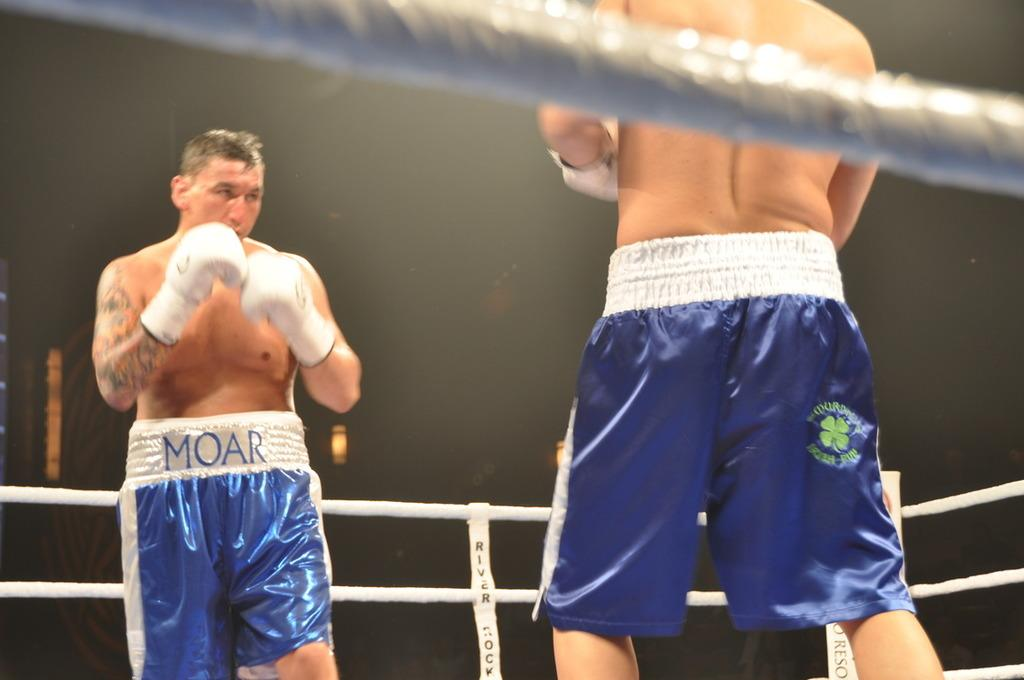<image>
Give a short and clear explanation of the subsequent image. Two boxers, one of whom is wearing a pair of shorts with the word Moar on the back. 